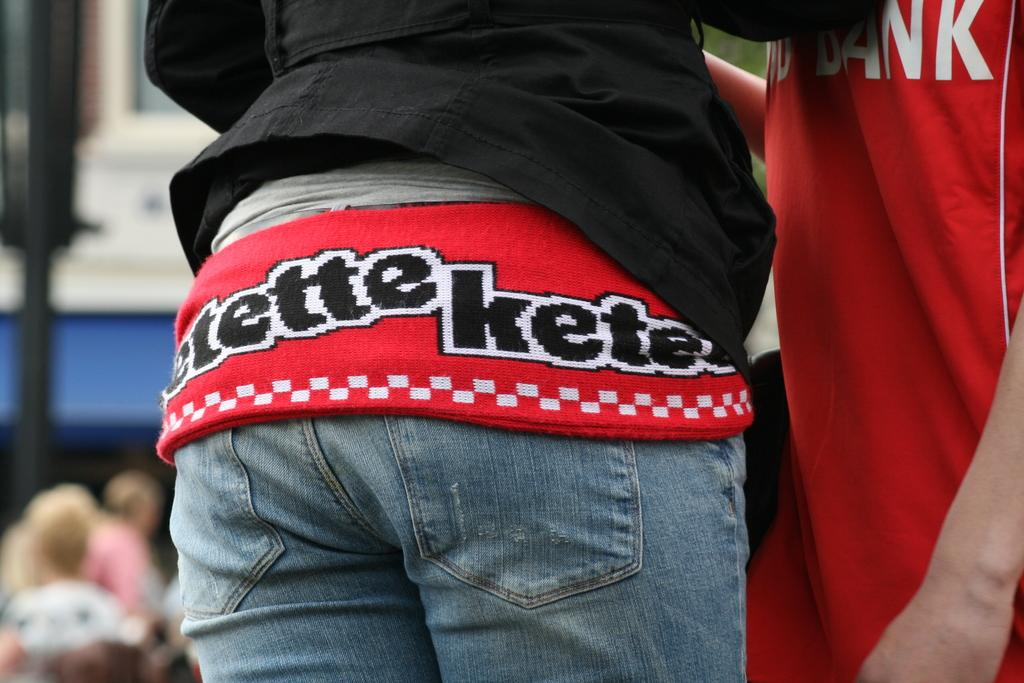<image>
Present a compact description of the photo's key features. the letters ket are on the back of a shirt a girl is wearing 